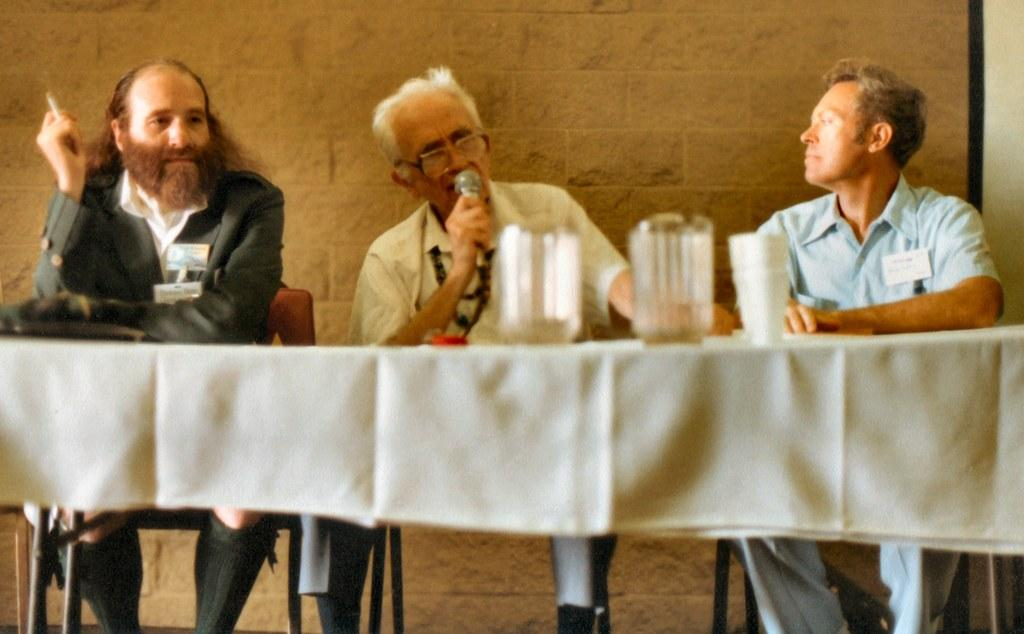How many men are present in the image? There are three men in the image. What are the men doing in the image? The men are sitting at a table. Is one of the men engaged in a specific activity? Yes, one of the men is speaking. What object is the speaking man holding in his hand? The speaking man is holding a microphone in his hand. What type of food is being served on the table in the image? There is no reference to food being served on the table in the image. Can you tell me where the receipt for the event is located in the image? There is no mention of a receipt or any event in the image. 